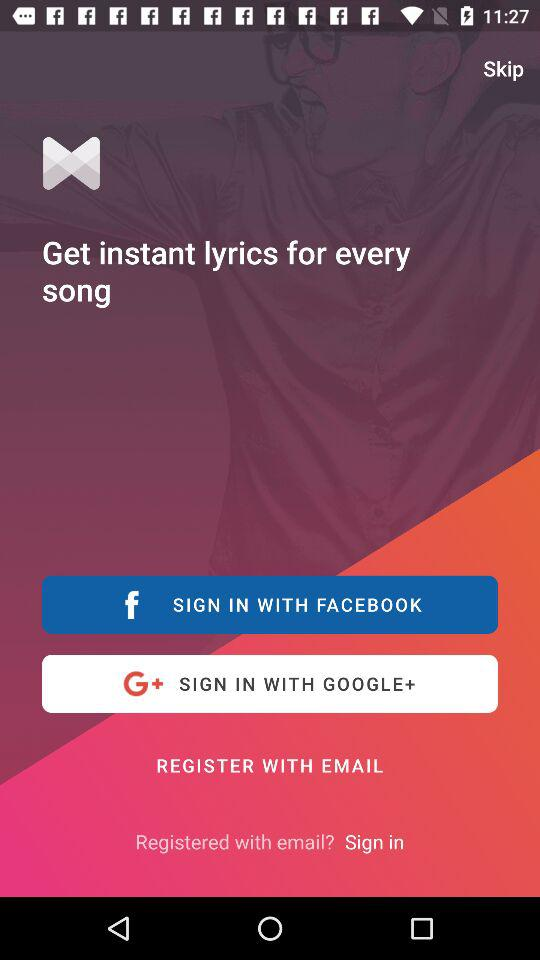What accounts can I use to sign in? You can use "FACEBOOK", "GOOGLE+" and "EMAIL" to sign in. 